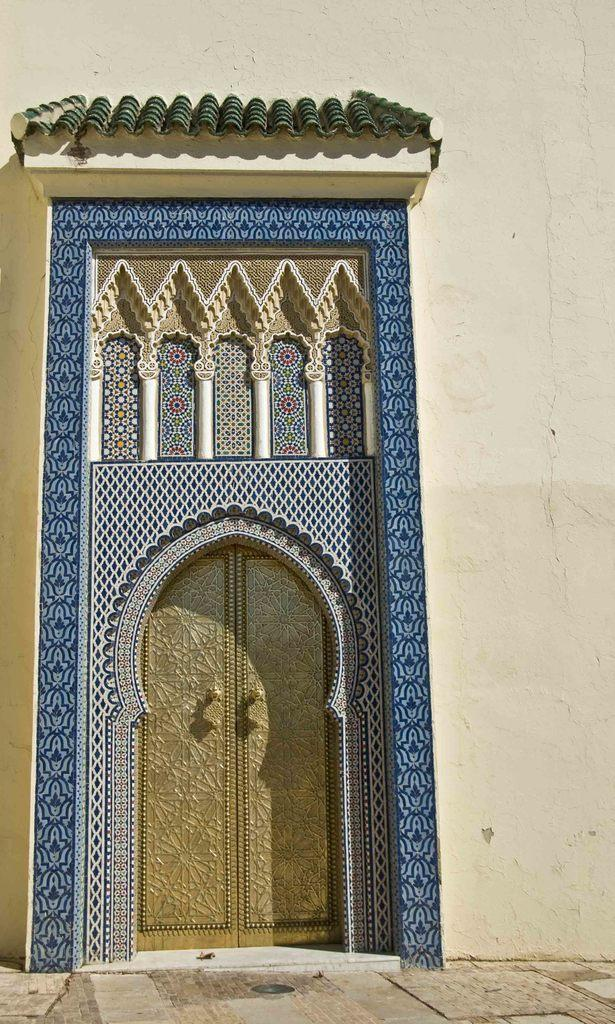What is the main subject of the image? The main subject of the image is the entrance of a building. What can be seen on the door at the entrance? The door at the entrance is painted with multiple colors on the top and sides. Is there a servant standing next to the door in the image? There is no servant present in the image. Can you see the father of the building owner in the image? There is no person, including a father, present in the image. 